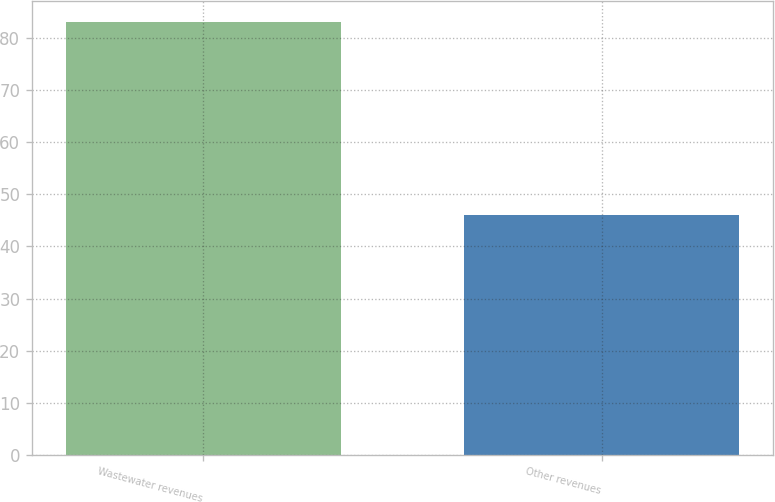Convert chart. <chart><loc_0><loc_0><loc_500><loc_500><bar_chart><fcel>Wastewater revenues<fcel>Other revenues<nl><fcel>83<fcel>46<nl></chart> 